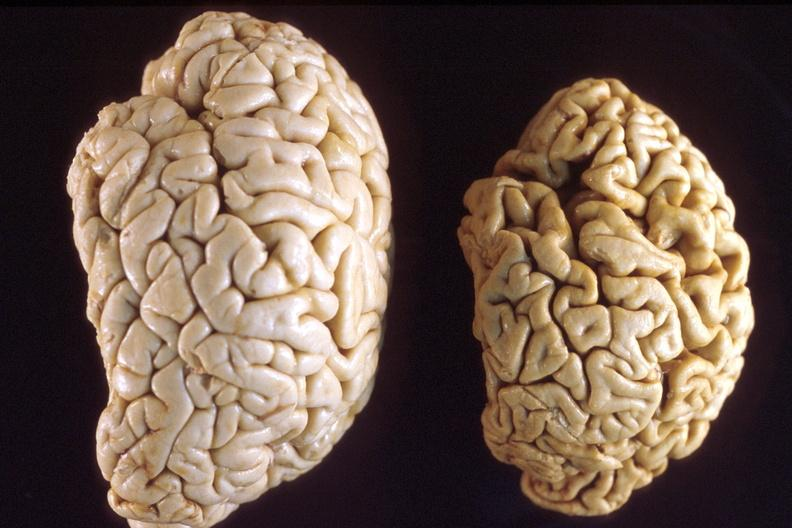s nervous present?
Answer the question using a single word or phrase. Yes 